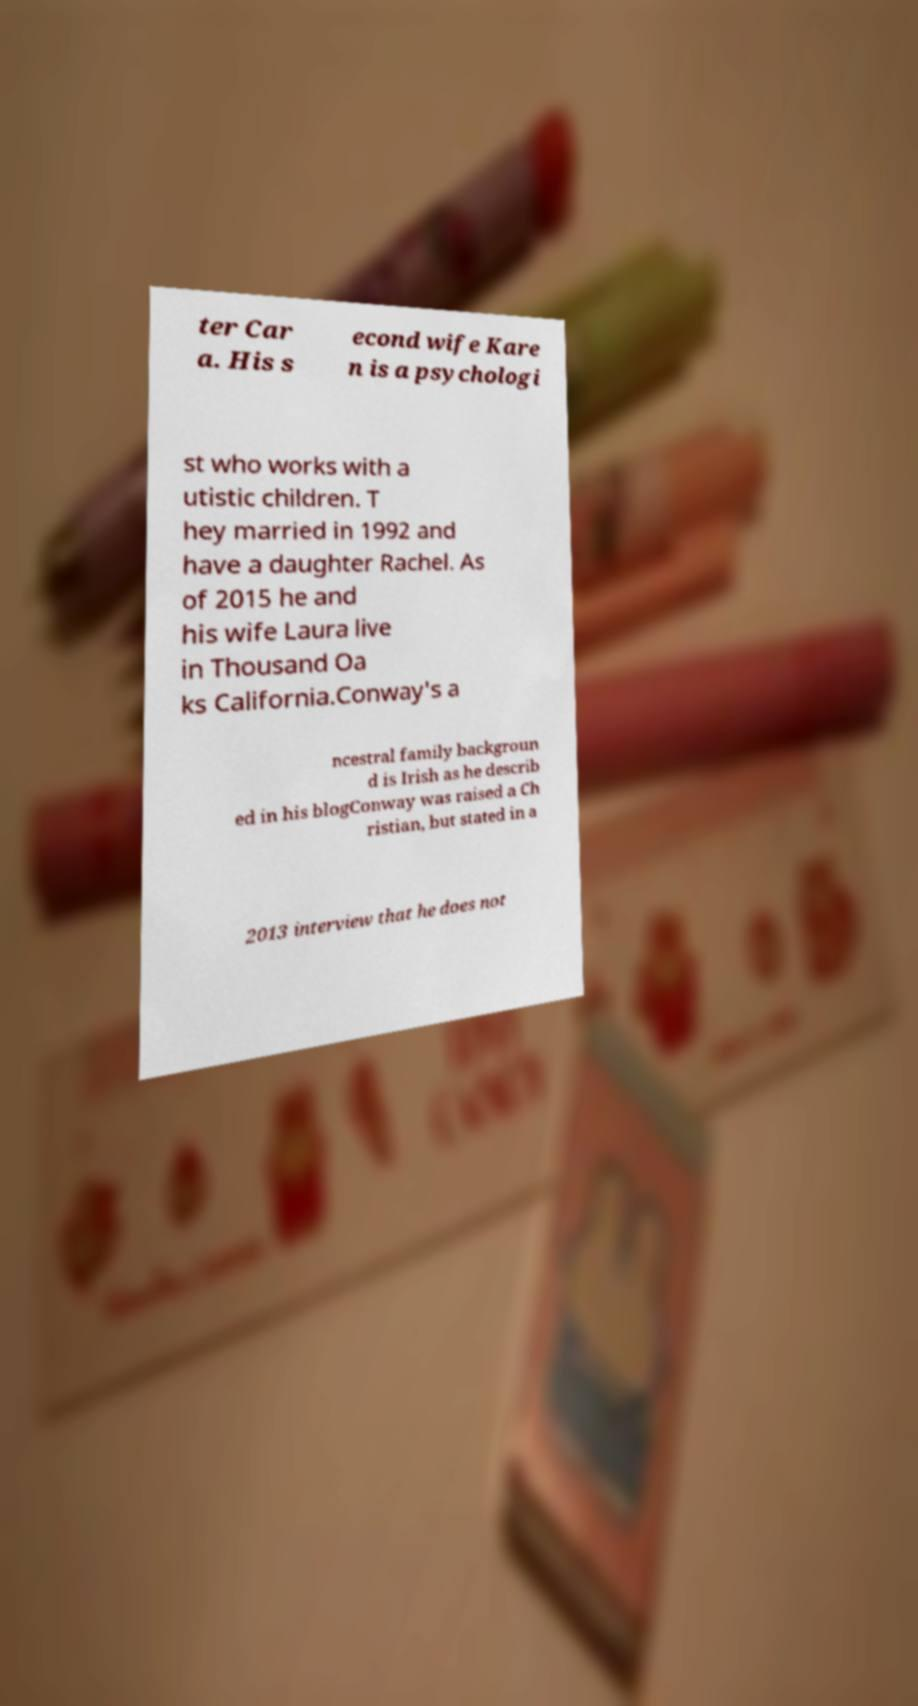Please identify and transcribe the text found in this image. ter Car a. His s econd wife Kare n is a psychologi st who works with a utistic children. T hey married in 1992 and have a daughter Rachel. As of 2015 he and his wife Laura live in Thousand Oa ks California.Conway's a ncestral family backgroun d is Irish as he describ ed in his blogConway was raised a Ch ristian, but stated in a 2013 interview that he does not 